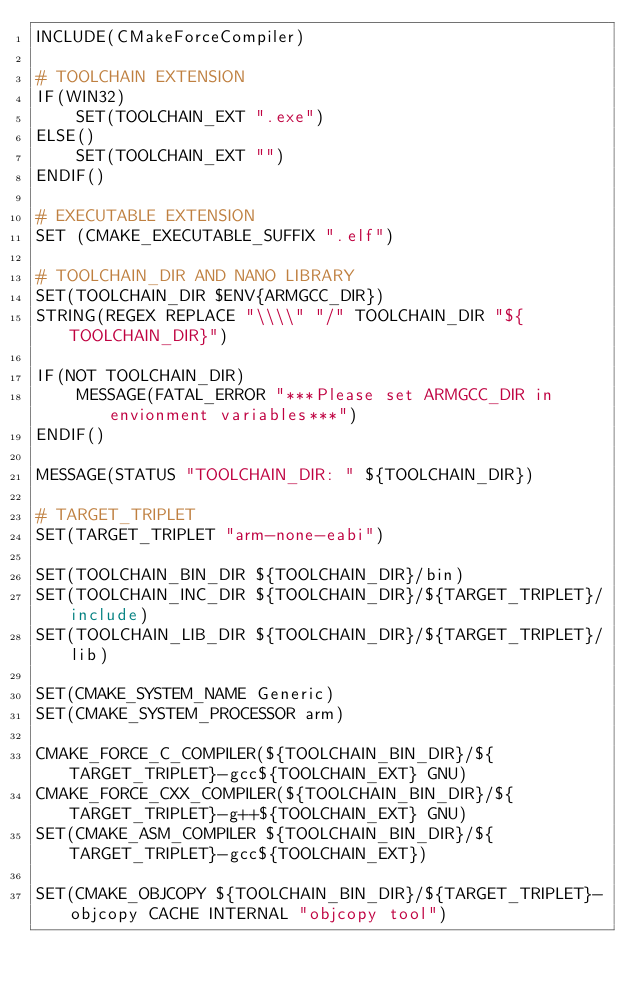Convert code to text. <code><loc_0><loc_0><loc_500><loc_500><_CMake_>INCLUDE(CMakeForceCompiler)

# TOOLCHAIN EXTENSION
IF(WIN32)
    SET(TOOLCHAIN_EXT ".exe")
ELSE()
    SET(TOOLCHAIN_EXT "")
ENDIF()

# EXECUTABLE EXTENSION
SET (CMAKE_EXECUTABLE_SUFFIX ".elf")

# TOOLCHAIN_DIR AND NANO LIBRARY
SET(TOOLCHAIN_DIR $ENV{ARMGCC_DIR})
STRING(REGEX REPLACE "\\\\" "/" TOOLCHAIN_DIR "${TOOLCHAIN_DIR}")

IF(NOT TOOLCHAIN_DIR)
    MESSAGE(FATAL_ERROR "***Please set ARMGCC_DIR in envionment variables***")
ENDIF()

MESSAGE(STATUS "TOOLCHAIN_DIR: " ${TOOLCHAIN_DIR})

# TARGET_TRIPLET
SET(TARGET_TRIPLET "arm-none-eabi")

SET(TOOLCHAIN_BIN_DIR ${TOOLCHAIN_DIR}/bin)
SET(TOOLCHAIN_INC_DIR ${TOOLCHAIN_DIR}/${TARGET_TRIPLET}/include)
SET(TOOLCHAIN_LIB_DIR ${TOOLCHAIN_DIR}/${TARGET_TRIPLET}/lib)

SET(CMAKE_SYSTEM_NAME Generic)
SET(CMAKE_SYSTEM_PROCESSOR arm)

CMAKE_FORCE_C_COMPILER(${TOOLCHAIN_BIN_DIR}/${TARGET_TRIPLET}-gcc${TOOLCHAIN_EXT} GNU)
CMAKE_FORCE_CXX_COMPILER(${TOOLCHAIN_BIN_DIR}/${TARGET_TRIPLET}-g++${TOOLCHAIN_EXT} GNU)
SET(CMAKE_ASM_COMPILER ${TOOLCHAIN_BIN_DIR}/${TARGET_TRIPLET}-gcc${TOOLCHAIN_EXT})

SET(CMAKE_OBJCOPY ${TOOLCHAIN_BIN_DIR}/${TARGET_TRIPLET}-objcopy CACHE INTERNAL "objcopy tool")</code> 